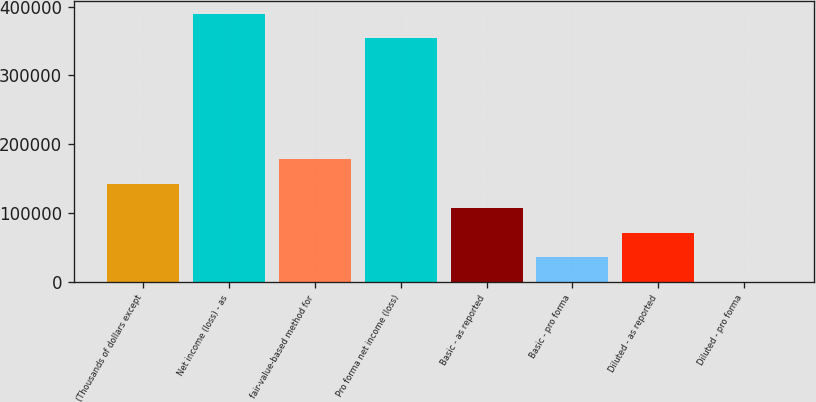Convert chart to OTSL. <chart><loc_0><loc_0><loc_500><loc_500><bar_chart><fcel>(Thousands of dollars except<fcel>Net income (loss) - as<fcel>fair-value-based method for<fcel>Pro forma net income (loss)<fcel>Basic - as reported<fcel>Basic - pro forma<fcel>Diluted - as reported<fcel>Diluted - pro forma<nl><fcel>142385<fcel>389218<fcel>177981<fcel>353622<fcel>106789<fcel>35596.9<fcel>71192.9<fcel>0.86<nl></chart> 